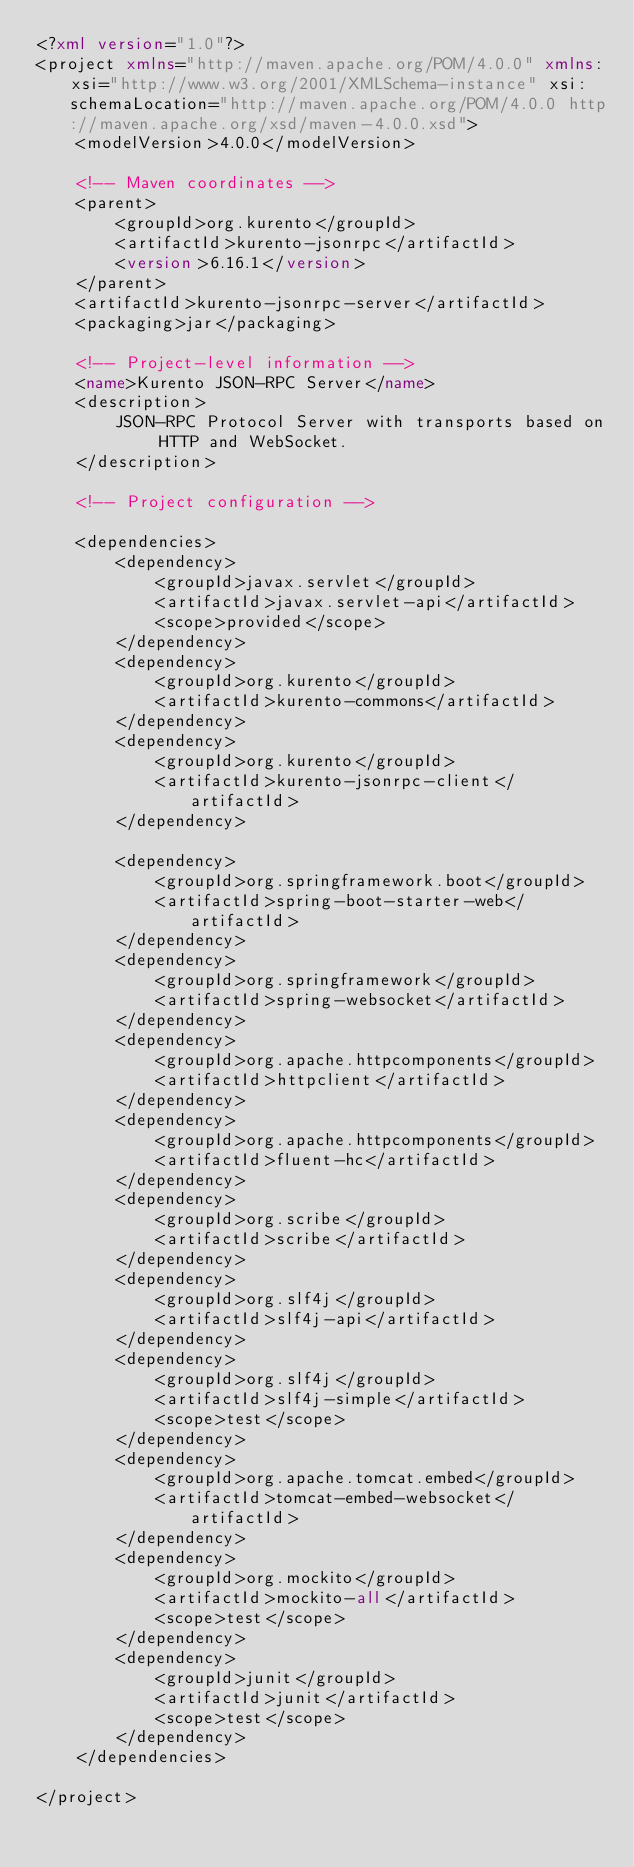<code> <loc_0><loc_0><loc_500><loc_500><_XML_><?xml version="1.0"?>
<project xmlns="http://maven.apache.org/POM/4.0.0" xmlns:xsi="http://www.w3.org/2001/XMLSchema-instance" xsi:schemaLocation="http://maven.apache.org/POM/4.0.0 http://maven.apache.org/xsd/maven-4.0.0.xsd">
	<modelVersion>4.0.0</modelVersion>

	<!-- Maven coordinates -->
	<parent>
		<groupId>org.kurento</groupId>
		<artifactId>kurento-jsonrpc</artifactId>
		<version>6.16.1</version>
	</parent>
	<artifactId>kurento-jsonrpc-server</artifactId>
	<packaging>jar</packaging>

	<!-- Project-level information -->
	<name>Kurento JSON-RPC Server</name>
	<description>
		JSON-RPC Protocol Server with transports based on HTTP and WebSocket.
	</description>

	<!-- Project configuration -->

	<dependencies>
		<dependency>
			<groupId>javax.servlet</groupId>
			<artifactId>javax.servlet-api</artifactId>
			<scope>provided</scope>
		</dependency>
		<dependency>
			<groupId>org.kurento</groupId>
			<artifactId>kurento-commons</artifactId>
		</dependency>
		<dependency>
			<groupId>org.kurento</groupId>
			<artifactId>kurento-jsonrpc-client</artifactId>
		</dependency>

		<dependency>
			<groupId>org.springframework.boot</groupId>
			<artifactId>spring-boot-starter-web</artifactId>
		</dependency>
		<dependency>
			<groupId>org.springframework</groupId>
			<artifactId>spring-websocket</artifactId>
		</dependency>
		<dependency>
			<groupId>org.apache.httpcomponents</groupId>
			<artifactId>httpclient</artifactId>
		</dependency>
		<dependency>
			<groupId>org.apache.httpcomponents</groupId>
			<artifactId>fluent-hc</artifactId>
		</dependency>
		<dependency>
			<groupId>org.scribe</groupId>
			<artifactId>scribe</artifactId>
		</dependency>
		<dependency>
			<groupId>org.slf4j</groupId>
			<artifactId>slf4j-api</artifactId>
		</dependency>
		<dependency>
			<groupId>org.slf4j</groupId>
			<artifactId>slf4j-simple</artifactId>
			<scope>test</scope>
		</dependency>
		<dependency>
			<groupId>org.apache.tomcat.embed</groupId>
			<artifactId>tomcat-embed-websocket</artifactId>
		</dependency>
		<dependency>
			<groupId>org.mockito</groupId>
			<artifactId>mockito-all</artifactId>
			<scope>test</scope>
		</dependency>
		<dependency>
			<groupId>junit</groupId>
			<artifactId>junit</artifactId>
			<scope>test</scope>
		</dependency>
	</dependencies>

</project>
</code> 